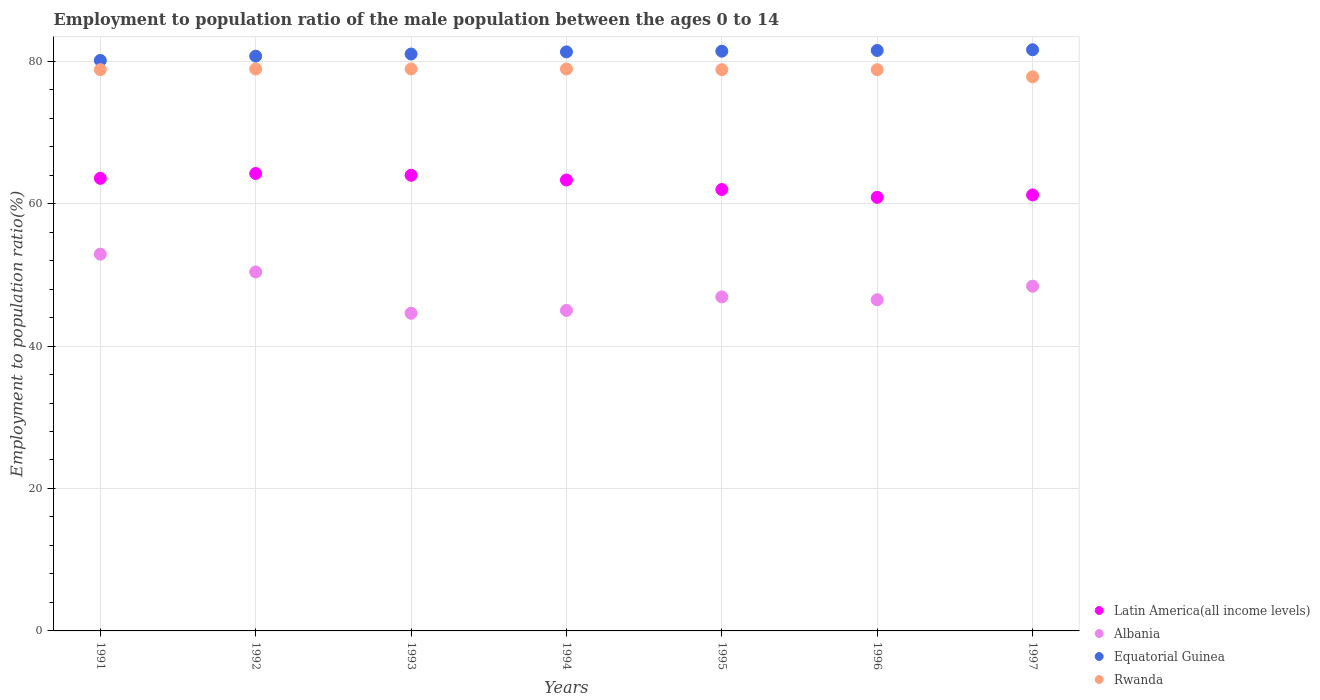Is the number of dotlines equal to the number of legend labels?
Offer a terse response. Yes. What is the employment to population ratio in Albania in 1997?
Offer a very short reply. 48.4. Across all years, what is the maximum employment to population ratio in Latin America(all income levels)?
Make the answer very short. 64.22. Across all years, what is the minimum employment to population ratio in Rwanda?
Provide a succinct answer. 77.8. In which year was the employment to population ratio in Albania maximum?
Keep it short and to the point. 1991. What is the total employment to population ratio in Rwanda in the graph?
Your answer should be very brief. 550.9. What is the difference between the employment to population ratio in Latin America(all income levels) in 1991 and that in 1992?
Offer a very short reply. -0.68. What is the difference between the employment to population ratio in Rwanda in 1994 and the employment to population ratio in Latin America(all income levels) in 1992?
Make the answer very short. 14.68. What is the average employment to population ratio in Albania per year?
Offer a terse response. 47.81. In the year 1996, what is the difference between the employment to population ratio in Latin America(all income levels) and employment to population ratio in Rwanda?
Your answer should be compact. -17.93. In how many years, is the employment to population ratio in Albania greater than 8 %?
Your response must be concise. 7. What is the ratio of the employment to population ratio in Equatorial Guinea in 1996 to that in 1997?
Your answer should be very brief. 1. What is the difference between the highest and the second highest employment to population ratio in Rwanda?
Make the answer very short. 0. What is the difference between the highest and the lowest employment to population ratio in Albania?
Your answer should be compact. 8.3. In how many years, is the employment to population ratio in Latin America(all income levels) greater than the average employment to population ratio in Latin America(all income levels) taken over all years?
Keep it short and to the point. 4. Is it the case that in every year, the sum of the employment to population ratio in Rwanda and employment to population ratio in Albania  is greater than the sum of employment to population ratio in Latin America(all income levels) and employment to population ratio in Equatorial Guinea?
Provide a short and direct response. No. Is it the case that in every year, the sum of the employment to population ratio in Latin America(all income levels) and employment to population ratio in Rwanda  is greater than the employment to population ratio in Equatorial Guinea?
Offer a terse response. Yes. Does the employment to population ratio in Rwanda monotonically increase over the years?
Your response must be concise. No. Is the employment to population ratio in Latin America(all income levels) strictly less than the employment to population ratio in Rwanda over the years?
Ensure brevity in your answer.  Yes. How many years are there in the graph?
Offer a terse response. 7. What is the difference between two consecutive major ticks on the Y-axis?
Provide a short and direct response. 20. Does the graph contain any zero values?
Your answer should be very brief. No. Where does the legend appear in the graph?
Provide a succinct answer. Bottom right. How many legend labels are there?
Provide a short and direct response. 4. How are the legend labels stacked?
Your answer should be very brief. Vertical. What is the title of the graph?
Give a very brief answer. Employment to population ratio of the male population between the ages 0 to 14. Does "Yemen, Rep." appear as one of the legend labels in the graph?
Make the answer very short. No. What is the label or title of the Y-axis?
Ensure brevity in your answer.  Employment to population ratio(%). What is the Employment to population ratio(%) of Latin America(all income levels) in 1991?
Make the answer very short. 63.55. What is the Employment to population ratio(%) in Albania in 1991?
Give a very brief answer. 52.9. What is the Employment to population ratio(%) of Equatorial Guinea in 1991?
Offer a very short reply. 80.1. What is the Employment to population ratio(%) of Rwanda in 1991?
Your response must be concise. 78.8. What is the Employment to population ratio(%) of Latin America(all income levels) in 1992?
Give a very brief answer. 64.22. What is the Employment to population ratio(%) in Albania in 1992?
Your answer should be very brief. 50.4. What is the Employment to population ratio(%) in Equatorial Guinea in 1992?
Your answer should be very brief. 80.7. What is the Employment to population ratio(%) in Rwanda in 1992?
Make the answer very short. 78.9. What is the Employment to population ratio(%) of Latin America(all income levels) in 1993?
Offer a very short reply. 63.98. What is the Employment to population ratio(%) of Albania in 1993?
Your answer should be compact. 44.6. What is the Employment to population ratio(%) in Rwanda in 1993?
Give a very brief answer. 78.9. What is the Employment to population ratio(%) in Latin America(all income levels) in 1994?
Offer a very short reply. 63.31. What is the Employment to population ratio(%) of Equatorial Guinea in 1994?
Make the answer very short. 81.3. What is the Employment to population ratio(%) of Rwanda in 1994?
Offer a very short reply. 78.9. What is the Employment to population ratio(%) in Latin America(all income levels) in 1995?
Your response must be concise. 61.98. What is the Employment to population ratio(%) of Albania in 1995?
Your answer should be compact. 46.9. What is the Employment to population ratio(%) of Equatorial Guinea in 1995?
Make the answer very short. 81.4. What is the Employment to population ratio(%) in Rwanda in 1995?
Offer a very short reply. 78.8. What is the Employment to population ratio(%) in Latin America(all income levels) in 1996?
Your response must be concise. 60.87. What is the Employment to population ratio(%) of Albania in 1996?
Keep it short and to the point. 46.5. What is the Employment to population ratio(%) of Equatorial Guinea in 1996?
Provide a short and direct response. 81.5. What is the Employment to population ratio(%) of Rwanda in 1996?
Your answer should be very brief. 78.8. What is the Employment to population ratio(%) in Latin America(all income levels) in 1997?
Your answer should be compact. 61.22. What is the Employment to population ratio(%) of Albania in 1997?
Your answer should be compact. 48.4. What is the Employment to population ratio(%) in Equatorial Guinea in 1997?
Your answer should be very brief. 81.6. What is the Employment to population ratio(%) of Rwanda in 1997?
Offer a very short reply. 77.8. Across all years, what is the maximum Employment to population ratio(%) of Latin America(all income levels)?
Keep it short and to the point. 64.22. Across all years, what is the maximum Employment to population ratio(%) in Albania?
Offer a terse response. 52.9. Across all years, what is the maximum Employment to population ratio(%) of Equatorial Guinea?
Provide a short and direct response. 81.6. Across all years, what is the maximum Employment to population ratio(%) in Rwanda?
Ensure brevity in your answer.  78.9. Across all years, what is the minimum Employment to population ratio(%) of Latin America(all income levels)?
Your response must be concise. 60.87. Across all years, what is the minimum Employment to population ratio(%) of Albania?
Your answer should be very brief. 44.6. Across all years, what is the minimum Employment to population ratio(%) in Equatorial Guinea?
Provide a succinct answer. 80.1. Across all years, what is the minimum Employment to population ratio(%) in Rwanda?
Make the answer very short. 77.8. What is the total Employment to population ratio(%) in Latin America(all income levels) in the graph?
Ensure brevity in your answer.  439.12. What is the total Employment to population ratio(%) of Albania in the graph?
Offer a terse response. 334.7. What is the total Employment to population ratio(%) of Equatorial Guinea in the graph?
Offer a very short reply. 567.6. What is the total Employment to population ratio(%) in Rwanda in the graph?
Give a very brief answer. 550.9. What is the difference between the Employment to population ratio(%) in Latin America(all income levels) in 1991 and that in 1992?
Provide a short and direct response. -0.68. What is the difference between the Employment to population ratio(%) in Albania in 1991 and that in 1992?
Make the answer very short. 2.5. What is the difference between the Employment to population ratio(%) of Rwanda in 1991 and that in 1992?
Offer a terse response. -0.1. What is the difference between the Employment to population ratio(%) in Latin America(all income levels) in 1991 and that in 1993?
Make the answer very short. -0.43. What is the difference between the Employment to population ratio(%) of Latin America(all income levels) in 1991 and that in 1994?
Ensure brevity in your answer.  0.24. What is the difference between the Employment to population ratio(%) of Albania in 1991 and that in 1994?
Provide a succinct answer. 7.9. What is the difference between the Employment to population ratio(%) in Equatorial Guinea in 1991 and that in 1994?
Offer a terse response. -1.2. What is the difference between the Employment to population ratio(%) of Latin America(all income levels) in 1991 and that in 1995?
Offer a very short reply. 1.57. What is the difference between the Employment to population ratio(%) of Albania in 1991 and that in 1995?
Provide a succinct answer. 6. What is the difference between the Employment to population ratio(%) in Rwanda in 1991 and that in 1995?
Ensure brevity in your answer.  0. What is the difference between the Employment to population ratio(%) of Latin America(all income levels) in 1991 and that in 1996?
Your answer should be very brief. 2.67. What is the difference between the Employment to population ratio(%) in Albania in 1991 and that in 1996?
Ensure brevity in your answer.  6.4. What is the difference between the Employment to population ratio(%) of Equatorial Guinea in 1991 and that in 1996?
Provide a short and direct response. -1.4. What is the difference between the Employment to population ratio(%) in Latin America(all income levels) in 1991 and that in 1997?
Give a very brief answer. 2.33. What is the difference between the Employment to population ratio(%) in Albania in 1991 and that in 1997?
Your response must be concise. 4.5. What is the difference between the Employment to population ratio(%) of Equatorial Guinea in 1991 and that in 1997?
Ensure brevity in your answer.  -1.5. What is the difference between the Employment to population ratio(%) in Rwanda in 1991 and that in 1997?
Your answer should be very brief. 1. What is the difference between the Employment to population ratio(%) in Latin America(all income levels) in 1992 and that in 1993?
Keep it short and to the point. 0.25. What is the difference between the Employment to population ratio(%) of Albania in 1992 and that in 1993?
Your answer should be very brief. 5.8. What is the difference between the Employment to population ratio(%) of Equatorial Guinea in 1992 and that in 1993?
Make the answer very short. -0.3. What is the difference between the Employment to population ratio(%) in Rwanda in 1992 and that in 1993?
Offer a very short reply. 0. What is the difference between the Employment to population ratio(%) of Latin America(all income levels) in 1992 and that in 1994?
Make the answer very short. 0.91. What is the difference between the Employment to population ratio(%) of Albania in 1992 and that in 1994?
Your answer should be very brief. 5.4. What is the difference between the Employment to population ratio(%) in Latin America(all income levels) in 1992 and that in 1995?
Provide a succinct answer. 2.25. What is the difference between the Employment to population ratio(%) of Latin America(all income levels) in 1992 and that in 1996?
Your response must be concise. 3.35. What is the difference between the Employment to population ratio(%) in Latin America(all income levels) in 1992 and that in 1997?
Make the answer very short. 3.01. What is the difference between the Employment to population ratio(%) in Albania in 1992 and that in 1997?
Your answer should be compact. 2. What is the difference between the Employment to population ratio(%) of Equatorial Guinea in 1992 and that in 1997?
Provide a succinct answer. -0.9. What is the difference between the Employment to population ratio(%) of Rwanda in 1992 and that in 1997?
Ensure brevity in your answer.  1.1. What is the difference between the Employment to population ratio(%) of Latin America(all income levels) in 1993 and that in 1994?
Offer a terse response. 0.67. What is the difference between the Employment to population ratio(%) of Latin America(all income levels) in 1993 and that in 1995?
Ensure brevity in your answer.  2. What is the difference between the Employment to population ratio(%) of Equatorial Guinea in 1993 and that in 1995?
Ensure brevity in your answer.  -0.4. What is the difference between the Employment to population ratio(%) of Rwanda in 1993 and that in 1995?
Your answer should be very brief. 0.1. What is the difference between the Employment to population ratio(%) of Latin America(all income levels) in 1993 and that in 1996?
Your answer should be compact. 3.1. What is the difference between the Employment to population ratio(%) in Albania in 1993 and that in 1996?
Offer a very short reply. -1.9. What is the difference between the Employment to population ratio(%) of Equatorial Guinea in 1993 and that in 1996?
Give a very brief answer. -0.5. What is the difference between the Employment to population ratio(%) of Latin America(all income levels) in 1993 and that in 1997?
Offer a terse response. 2.76. What is the difference between the Employment to population ratio(%) of Latin America(all income levels) in 1994 and that in 1995?
Make the answer very short. 1.33. What is the difference between the Employment to population ratio(%) in Rwanda in 1994 and that in 1995?
Ensure brevity in your answer.  0.1. What is the difference between the Employment to population ratio(%) in Latin America(all income levels) in 1994 and that in 1996?
Keep it short and to the point. 2.44. What is the difference between the Employment to population ratio(%) of Albania in 1994 and that in 1996?
Keep it short and to the point. -1.5. What is the difference between the Employment to population ratio(%) of Latin America(all income levels) in 1994 and that in 1997?
Your response must be concise. 2.09. What is the difference between the Employment to population ratio(%) in Equatorial Guinea in 1994 and that in 1997?
Offer a terse response. -0.3. What is the difference between the Employment to population ratio(%) in Latin America(all income levels) in 1995 and that in 1996?
Keep it short and to the point. 1.1. What is the difference between the Employment to population ratio(%) of Albania in 1995 and that in 1996?
Offer a very short reply. 0.4. What is the difference between the Employment to population ratio(%) of Latin America(all income levels) in 1995 and that in 1997?
Ensure brevity in your answer.  0.76. What is the difference between the Employment to population ratio(%) in Latin America(all income levels) in 1996 and that in 1997?
Offer a terse response. -0.34. What is the difference between the Employment to population ratio(%) in Albania in 1996 and that in 1997?
Provide a succinct answer. -1.9. What is the difference between the Employment to population ratio(%) of Equatorial Guinea in 1996 and that in 1997?
Offer a very short reply. -0.1. What is the difference between the Employment to population ratio(%) in Latin America(all income levels) in 1991 and the Employment to population ratio(%) in Albania in 1992?
Provide a short and direct response. 13.15. What is the difference between the Employment to population ratio(%) in Latin America(all income levels) in 1991 and the Employment to population ratio(%) in Equatorial Guinea in 1992?
Give a very brief answer. -17.15. What is the difference between the Employment to population ratio(%) in Latin America(all income levels) in 1991 and the Employment to population ratio(%) in Rwanda in 1992?
Your response must be concise. -15.35. What is the difference between the Employment to population ratio(%) of Albania in 1991 and the Employment to population ratio(%) of Equatorial Guinea in 1992?
Keep it short and to the point. -27.8. What is the difference between the Employment to population ratio(%) in Equatorial Guinea in 1991 and the Employment to population ratio(%) in Rwanda in 1992?
Your answer should be compact. 1.2. What is the difference between the Employment to population ratio(%) in Latin America(all income levels) in 1991 and the Employment to population ratio(%) in Albania in 1993?
Make the answer very short. 18.95. What is the difference between the Employment to population ratio(%) of Latin America(all income levels) in 1991 and the Employment to population ratio(%) of Equatorial Guinea in 1993?
Make the answer very short. -17.45. What is the difference between the Employment to population ratio(%) in Latin America(all income levels) in 1991 and the Employment to population ratio(%) in Rwanda in 1993?
Provide a short and direct response. -15.35. What is the difference between the Employment to population ratio(%) in Albania in 1991 and the Employment to population ratio(%) in Equatorial Guinea in 1993?
Make the answer very short. -28.1. What is the difference between the Employment to population ratio(%) in Albania in 1991 and the Employment to population ratio(%) in Rwanda in 1993?
Provide a succinct answer. -26. What is the difference between the Employment to population ratio(%) in Equatorial Guinea in 1991 and the Employment to population ratio(%) in Rwanda in 1993?
Offer a terse response. 1.2. What is the difference between the Employment to population ratio(%) in Latin America(all income levels) in 1991 and the Employment to population ratio(%) in Albania in 1994?
Your answer should be very brief. 18.55. What is the difference between the Employment to population ratio(%) in Latin America(all income levels) in 1991 and the Employment to population ratio(%) in Equatorial Guinea in 1994?
Provide a short and direct response. -17.75. What is the difference between the Employment to population ratio(%) of Latin America(all income levels) in 1991 and the Employment to population ratio(%) of Rwanda in 1994?
Provide a short and direct response. -15.35. What is the difference between the Employment to population ratio(%) of Albania in 1991 and the Employment to population ratio(%) of Equatorial Guinea in 1994?
Provide a short and direct response. -28.4. What is the difference between the Employment to population ratio(%) in Albania in 1991 and the Employment to population ratio(%) in Rwanda in 1994?
Keep it short and to the point. -26. What is the difference between the Employment to population ratio(%) of Latin America(all income levels) in 1991 and the Employment to population ratio(%) of Albania in 1995?
Give a very brief answer. 16.65. What is the difference between the Employment to population ratio(%) in Latin America(all income levels) in 1991 and the Employment to population ratio(%) in Equatorial Guinea in 1995?
Offer a very short reply. -17.85. What is the difference between the Employment to population ratio(%) of Latin America(all income levels) in 1991 and the Employment to population ratio(%) of Rwanda in 1995?
Offer a terse response. -15.25. What is the difference between the Employment to population ratio(%) of Albania in 1991 and the Employment to population ratio(%) of Equatorial Guinea in 1995?
Make the answer very short. -28.5. What is the difference between the Employment to population ratio(%) in Albania in 1991 and the Employment to population ratio(%) in Rwanda in 1995?
Your response must be concise. -25.9. What is the difference between the Employment to population ratio(%) of Latin America(all income levels) in 1991 and the Employment to population ratio(%) of Albania in 1996?
Keep it short and to the point. 17.05. What is the difference between the Employment to population ratio(%) of Latin America(all income levels) in 1991 and the Employment to population ratio(%) of Equatorial Guinea in 1996?
Your answer should be very brief. -17.95. What is the difference between the Employment to population ratio(%) in Latin America(all income levels) in 1991 and the Employment to population ratio(%) in Rwanda in 1996?
Your answer should be compact. -15.25. What is the difference between the Employment to population ratio(%) of Albania in 1991 and the Employment to population ratio(%) of Equatorial Guinea in 1996?
Keep it short and to the point. -28.6. What is the difference between the Employment to population ratio(%) of Albania in 1991 and the Employment to population ratio(%) of Rwanda in 1996?
Your answer should be compact. -25.9. What is the difference between the Employment to population ratio(%) of Latin America(all income levels) in 1991 and the Employment to population ratio(%) of Albania in 1997?
Your answer should be compact. 15.15. What is the difference between the Employment to population ratio(%) of Latin America(all income levels) in 1991 and the Employment to population ratio(%) of Equatorial Guinea in 1997?
Provide a short and direct response. -18.05. What is the difference between the Employment to population ratio(%) of Latin America(all income levels) in 1991 and the Employment to population ratio(%) of Rwanda in 1997?
Provide a succinct answer. -14.25. What is the difference between the Employment to population ratio(%) of Albania in 1991 and the Employment to population ratio(%) of Equatorial Guinea in 1997?
Provide a short and direct response. -28.7. What is the difference between the Employment to population ratio(%) in Albania in 1991 and the Employment to population ratio(%) in Rwanda in 1997?
Your answer should be compact. -24.9. What is the difference between the Employment to population ratio(%) in Equatorial Guinea in 1991 and the Employment to population ratio(%) in Rwanda in 1997?
Make the answer very short. 2.3. What is the difference between the Employment to population ratio(%) in Latin America(all income levels) in 1992 and the Employment to population ratio(%) in Albania in 1993?
Keep it short and to the point. 19.62. What is the difference between the Employment to population ratio(%) in Latin America(all income levels) in 1992 and the Employment to population ratio(%) in Equatorial Guinea in 1993?
Give a very brief answer. -16.78. What is the difference between the Employment to population ratio(%) of Latin America(all income levels) in 1992 and the Employment to population ratio(%) of Rwanda in 1993?
Your answer should be compact. -14.68. What is the difference between the Employment to population ratio(%) of Albania in 1992 and the Employment to population ratio(%) of Equatorial Guinea in 1993?
Provide a succinct answer. -30.6. What is the difference between the Employment to population ratio(%) in Albania in 1992 and the Employment to population ratio(%) in Rwanda in 1993?
Offer a very short reply. -28.5. What is the difference between the Employment to population ratio(%) in Latin America(all income levels) in 1992 and the Employment to population ratio(%) in Albania in 1994?
Ensure brevity in your answer.  19.22. What is the difference between the Employment to population ratio(%) in Latin America(all income levels) in 1992 and the Employment to population ratio(%) in Equatorial Guinea in 1994?
Keep it short and to the point. -17.08. What is the difference between the Employment to population ratio(%) in Latin America(all income levels) in 1992 and the Employment to population ratio(%) in Rwanda in 1994?
Give a very brief answer. -14.68. What is the difference between the Employment to population ratio(%) in Albania in 1992 and the Employment to population ratio(%) in Equatorial Guinea in 1994?
Your response must be concise. -30.9. What is the difference between the Employment to population ratio(%) in Albania in 1992 and the Employment to population ratio(%) in Rwanda in 1994?
Your answer should be compact. -28.5. What is the difference between the Employment to population ratio(%) in Equatorial Guinea in 1992 and the Employment to population ratio(%) in Rwanda in 1994?
Provide a succinct answer. 1.8. What is the difference between the Employment to population ratio(%) of Latin America(all income levels) in 1992 and the Employment to population ratio(%) of Albania in 1995?
Offer a terse response. 17.32. What is the difference between the Employment to population ratio(%) of Latin America(all income levels) in 1992 and the Employment to population ratio(%) of Equatorial Guinea in 1995?
Provide a succinct answer. -17.18. What is the difference between the Employment to population ratio(%) of Latin America(all income levels) in 1992 and the Employment to population ratio(%) of Rwanda in 1995?
Make the answer very short. -14.58. What is the difference between the Employment to population ratio(%) of Albania in 1992 and the Employment to population ratio(%) of Equatorial Guinea in 1995?
Provide a short and direct response. -31. What is the difference between the Employment to population ratio(%) of Albania in 1992 and the Employment to population ratio(%) of Rwanda in 1995?
Your response must be concise. -28.4. What is the difference between the Employment to population ratio(%) in Latin America(all income levels) in 1992 and the Employment to population ratio(%) in Albania in 1996?
Your answer should be very brief. 17.72. What is the difference between the Employment to population ratio(%) of Latin America(all income levels) in 1992 and the Employment to population ratio(%) of Equatorial Guinea in 1996?
Provide a short and direct response. -17.28. What is the difference between the Employment to population ratio(%) in Latin America(all income levels) in 1992 and the Employment to population ratio(%) in Rwanda in 1996?
Keep it short and to the point. -14.58. What is the difference between the Employment to population ratio(%) of Albania in 1992 and the Employment to population ratio(%) of Equatorial Guinea in 1996?
Provide a succinct answer. -31.1. What is the difference between the Employment to population ratio(%) of Albania in 1992 and the Employment to population ratio(%) of Rwanda in 1996?
Your answer should be compact. -28.4. What is the difference between the Employment to population ratio(%) in Latin America(all income levels) in 1992 and the Employment to population ratio(%) in Albania in 1997?
Keep it short and to the point. 15.82. What is the difference between the Employment to population ratio(%) in Latin America(all income levels) in 1992 and the Employment to population ratio(%) in Equatorial Guinea in 1997?
Provide a short and direct response. -17.38. What is the difference between the Employment to population ratio(%) of Latin America(all income levels) in 1992 and the Employment to population ratio(%) of Rwanda in 1997?
Your answer should be compact. -13.58. What is the difference between the Employment to population ratio(%) of Albania in 1992 and the Employment to population ratio(%) of Equatorial Guinea in 1997?
Provide a succinct answer. -31.2. What is the difference between the Employment to population ratio(%) of Albania in 1992 and the Employment to population ratio(%) of Rwanda in 1997?
Provide a short and direct response. -27.4. What is the difference between the Employment to population ratio(%) in Equatorial Guinea in 1992 and the Employment to population ratio(%) in Rwanda in 1997?
Your answer should be very brief. 2.9. What is the difference between the Employment to population ratio(%) of Latin America(all income levels) in 1993 and the Employment to population ratio(%) of Albania in 1994?
Provide a succinct answer. 18.98. What is the difference between the Employment to population ratio(%) in Latin America(all income levels) in 1993 and the Employment to population ratio(%) in Equatorial Guinea in 1994?
Provide a short and direct response. -17.32. What is the difference between the Employment to population ratio(%) in Latin America(all income levels) in 1993 and the Employment to population ratio(%) in Rwanda in 1994?
Your answer should be very brief. -14.92. What is the difference between the Employment to population ratio(%) of Albania in 1993 and the Employment to population ratio(%) of Equatorial Guinea in 1994?
Your answer should be compact. -36.7. What is the difference between the Employment to population ratio(%) of Albania in 1993 and the Employment to population ratio(%) of Rwanda in 1994?
Your answer should be compact. -34.3. What is the difference between the Employment to population ratio(%) in Equatorial Guinea in 1993 and the Employment to population ratio(%) in Rwanda in 1994?
Provide a succinct answer. 2.1. What is the difference between the Employment to population ratio(%) of Latin America(all income levels) in 1993 and the Employment to population ratio(%) of Albania in 1995?
Keep it short and to the point. 17.08. What is the difference between the Employment to population ratio(%) of Latin America(all income levels) in 1993 and the Employment to population ratio(%) of Equatorial Guinea in 1995?
Your response must be concise. -17.42. What is the difference between the Employment to population ratio(%) of Latin America(all income levels) in 1993 and the Employment to population ratio(%) of Rwanda in 1995?
Provide a short and direct response. -14.82. What is the difference between the Employment to population ratio(%) of Albania in 1993 and the Employment to population ratio(%) of Equatorial Guinea in 1995?
Offer a terse response. -36.8. What is the difference between the Employment to population ratio(%) of Albania in 1993 and the Employment to population ratio(%) of Rwanda in 1995?
Provide a succinct answer. -34.2. What is the difference between the Employment to population ratio(%) in Latin America(all income levels) in 1993 and the Employment to population ratio(%) in Albania in 1996?
Your response must be concise. 17.48. What is the difference between the Employment to population ratio(%) of Latin America(all income levels) in 1993 and the Employment to population ratio(%) of Equatorial Guinea in 1996?
Provide a short and direct response. -17.52. What is the difference between the Employment to population ratio(%) of Latin America(all income levels) in 1993 and the Employment to population ratio(%) of Rwanda in 1996?
Provide a short and direct response. -14.82. What is the difference between the Employment to population ratio(%) in Albania in 1993 and the Employment to population ratio(%) in Equatorial Guinea in 1996?
Provide a succinct answer. -36.9. What is the difference between the Employment to population ratio(%) in Albania in 1993 and the Employment to population ratio(%) in Rwanda in 1996?
Your answer should be compact. -34.2. What is the difference between the Employment to population ratio(%) of Latin America(all income levels) in 1993 and the Employment to population ratio(%) of Albania in 1997?
Offer a terse response. 15.58. What is the difference between the Employment to population ratio(%) of Latin America(all income levels) in 1993 and the Employment to population ratio(%) of Equatorial Guinea in 1997?
Offer a terse response. -17.62. What is the difference between the Employment to population ratio(%) of Latin America(all income levels) in 1993 and the Employment to population ratio(%) of Rwanda in 1997?
Provide a short and direct response. -13.82. What is the difference between the Employment to population ratio(%) of Albania in 1993 and the Employment to population ratio(%) of Equatorial Guinea in 1997?
Your answer should be very brief. -37. What is the difference between the Employment to population ratio(%) in Albania in 1993 and the Employment to population ratio(%) in Rwanda in 1997?
Provide a short and direct response. -33.2. What is the difference between the Employment to population ratio(%) in Latin America(all income levels) in 1994 and the Employment to population ratio(%) in Albania in 1995?
Keep it short and to the point. 16.41. What is the difference between the Employment to population ratio(%) of Latin America(all income levels) in 1994 and the Employment to population ratio(%) of Equatorial Guinea in 1995?
Your answer should be compact. -18.09. What is the difference between the Employment to population ratio(%) in Latin America(all income levels) in 1994 and the Employment to population ratio(%) in Rwanda in 1995?
Your response must be concise. -15.49. What is the difference between the Employment to population ratio(%) in Albania in 1994 and the Employment to population ratio(%) in Equatorial Guinea in 1995?
Provide a short and direct response. -36.4. What is the difference between the Employment to population ratio(%) in Albania in 1994 and the Employment to population ratio(%) in Rwanda in 1995?
Offer a very short reply. -33.8. What is the difference between the Employment to population ratio(%) in Equatorial Guinea in 1994 and the Employment to population ratio(%) in Rwanda in 1995?
Provide a short and direct response. 2.5. What is the difference between the Employment to population ratio(%) of Latin America(all income levels) in 1994 and the Employment to population ratio(%) of Albania in 1996?
Your answer should be very brief. 16.81. What is the difference between the Employment to population ratio(%) in Latin America(all income levels) in 1994 and the Employment to population ratio(%) in Equatorial Guinea in 1996?
Your response must be concise. -18.19. What is the difference between the Employment to population ratio(%) in Latin America(all income levels) in 1994 and the Employment to population ratio(%) in Rwanda in 1996?
Provide a succinct answer. -15.49. What is the difference between the Employment to population ratio(%) in Albania in 1994 and the Employment to population ratio(%) in Equatorial Guinea in 1996?
Keep it short and to the point. -36.5. What is the difference between the Employment to population ratio(%) of Albania in 1994 and the Employment to population ratio(%) of Rwanda in 1996?
Give a very brief answer. -33.8. What is the difference between the Employment to population ratio(%) of Latin America(all income levels) in 1994 and the Employment to population ratio(%) of Albania in 1997?
Provide a succinct answer. 14.91. What is the difference between the Employment to population ratio(%) in Latin America(all income levels) in 1994 and the Employment to population ratio(%) in Equatorial Guinea in 1997?
Offer a terse response. -18.29. What is the difference between the Employment to population ratio(%) of Latin America(all income levels) in 1994 and the Employment to population ratio(%) of Rwanda in 1997?
Your answer should be very brief. -14.49. What is the difference between the Employment to population ratio(%) of Albania in 1994 and the Employment to population ratio(%) of Equatorial Guinea in 1997?
Your response must be concise. -36.6. What is the difference between the Employment to population ratio(%) of Albania in 1994 and the Employment to population ratio(%) of Rwanda in 1997?
Keep it short and to the point. -32.8. What is the difference between the Employment to population ratio(%) of Latin America(all income levels) in 1995 and the Employment to population ratio(%) of Albania in 1996?
Your answer should be compact. 15.48. What is the difference between the Employment to population ratio(%) of Latin America(all income levels) in 1995 and the Employment to population ratio(%) of Equatorial Guinea in 1996?
Offer a very short reply. -19.52. What is the difference between the Employment to population ratio(%) in Latin America(all income levels) in 1995 and the Employment to population ratio(%) in Rwanda in 1996?
Your response must be concise. -16.82. What is the difference between the Employment to population ratio(%) in Albania in 1995 and the Employment to population ratio(%) in Equatorial Guinea in 1996?
Keep it short and to the point. -34.6. What is the difference between the Employment to population ratio(%) in Albania in 1995 and the Employment to population ratio(%) in Rwanda in 1996?
Keep it short and to the point. -31.9. What is the difference between the Employment to population ratio(%) of Equatorial Guinea in 1995 and the Employment to population ratio(%) of Rwanda in 1996?
Your answer should be compact. 2.6. What is the difference between the Employment to population ratio(%) in Latin America(all income levels) in 1995 and the Employment to population ratio(%) in Albania in 1997?
Your answer should be very brief. 13.58. What is the difference between the Employment to population ratio(%) in Latin America(all income levels) in 1995 and the Employment to population ratio(%) in Equatorial Guinea in 1997?
Provide a short and direct response. -19.62. What is the difference between the Employment to population ratio(%) in Latin America(all income levels) in 1995 and the Employment to population ratio(%) in Rwanda in 1997?
Your answer should be compact. -15.82. What is the difference between the Employment to population ratio(%) in Albania in 1995 and the Employment to population ratio(%) in Equatorial Guinea in 1997?
Your answer should be compact. -34.7. What is the difference between the Employment to population ratio(%) in Albania in 1995 and the Employment to population ratio(%) in Rwanda in 1997?
Keep it short and to the point. -30.9. What is the difference between the Employment to population ratio(%) of Equatorial Guinea in 1995 and the Employment to population ratio(%) of Rwanda in 1997?
Your response must be concise. 3.6. What is the difference between the Employment to population ratio(%) in Latin America(all income levels) in 1996 and the Employment to population ratio(%) in Albania in 1997?
Give a very brief answer. 12.47. What is the difference between the Employment to population ratio(%) in Latin America(all income levels) in 1996 and the Employment to population ratio(%) in Equatorial Guinea in 1997?
Ensure brevity in your answer.  -20.73. What is the difference between the Employment to population ratio(%) of Latin America(all income levels) in 1996 and the Employment to population ratio(%) of Rwanda in 1997?
Your answer should be very brief. -16.93. What is the difference between the Employment to population ratio(%) of Albania in 1996 and the Employment to population ratio(%) of Equatorial Guinea in 1997?
Ensure brevity in your answer.  -35.1. What is the difference between the Employment to population ratio(%) of Albania in 1996 and the Employment to population ratio(%) of Rwanda in 1997?
Keep it short and to the point. -31.3. What is the difference between the Employment to population ratio(%) in Equatorial Guinea in 1996 and the Employment to population ratio(%) in Rwanda in 1997?
Your answer should be very brief. 3.7. What is the average Employment to population ratio(%) of Latin America(all income levels) per year?
Offer a very short reply. 62.73. What is the average Employment to population ratio(%) in Albania per year?
Ensure brevity in your answer.  47.81. What is the average Employment to population ratio(%) in Equatorial Guinea per year?
Ensure brevity in your answer.  81.09. What is the average Employment to population ratio(%) of Rwanda per year?
Ensure brevity in your answer.  78.7. In the year 1991, what is the difference between the Employment to population ratio(%) of Latin America(all income levels) and Employment to population ratio(%) of Albania?
Offer a terse response. 10.65. In the year 1991, what is the difference between the Employment to population ratio(%) in Latin America(all income levels) and Employment to population ratio(%) in Equatorial Guinea?
Provide a succinct answer. -16.55. In the year 1991, what is the difference between the Employment to population ratio(%) in Latin America(all income levels) and Employment to population ratio(%) in Rwanda?
Keep it short and to the point. -15.25. In the year 1991, what is the difference between the Employment to population ratio(%) in Albania and Employment to population ratio(%) in Equatorial Guinea?
Provide a succinct answer. -27.2. In the year 1991, what is the difference between the Employment to population ratio(%) of Albania and Employment to population ratio(%) of Rwanda?
Make the answer very short. -25.9. In the year 1991, what is the difference between the Employment to population ratio(%) of Equatorial Guinea and Employment to population ratio(%) of Rwanda?
Make the answer very short. 1.3. In the year 1992, what is the difference between the Employment to population ratio(%) in Latin America(all income levels) and Employment to population ratio(%) in Albania?
Offer a terse response. 13.82. In the year 1992, what is the difference between the Employment to population ratio(%) in Latin America(all income levels) and Employment to population ratio(%) in Equatorial Guinea?
Your answer should be very brief. -16.48. In the year 1992, what is the difference between the Employment to population ratio(%) in Latin America(all income levels) and Employment to population ratio(%) in Rwanda?
Offer a terse response. -14.68. In the year 1992, what is the difference between the Employment to population ratio(%) of Albania and Employment to population ratio(%) of Equatorial Guinea?
Give a very brief answer. -30.3. In the year 1992, what is the difference between the Employment to population ratio(%) of Albania and Employment to population ratio(%) of Rwanda?
Make the answer very short. -28.5. In the year 1992, what is the difference between the Employment to population ratio(%) in Equatorial Guinea and Employment to population ratio(%) in Rwanda?
Make the answer very short. 1.8. In the year 1993, what is the difference between the Employment to population ratio(%) in Latin America(all income levels) and Employment to population ratio(%) in Albania?
Offer a terse response. 19.38. In the year 1993, what is the difference between the Employment to population ratio(%) in Latin America(all income levels) and Employment to population ratio(%) in Equatorial Guinea?
Keep it short and to the point. -17.02. In the year 1993, what is the difference between the Employment to population ratio(%) in Latin America(all income levels) and Employment to population ratio(%) in Rwanda?
Provide a short and direct response. -14.92. In the year 1993, what is the difference between the Employment to population ratio(%) in Albania and Employment to population ratio(%) in Equatorial Guinea?
Your answer should be compact. -36.4. In the year 1993, what is the difference between the Employment to population ratio(%) of Albania and Employment to population ratio(%) of Rwanda?
Provide a short and direct response. -34.3. In the year 1994, what is the difference between the Employment to population ratio(%) of Latin America(all income levels) and Employment to population ratio(%) of Albania?
Ensure brevity in your answer.  18.31. In the year 1994, what is the difference between the Employment to population ratio(%) in Latin America(all income levels) and Employment to population ratio(%) in Equatorial Guinea?
Provide a short and direct response. -17.99. In the year 1994, what is the difference between the Employment to population ratio(%) in Latin America(all income levels) and Employment to population ratio(%) in Rwanda?
Make the answer very short. -15.59. In the year 1994, what is the difference between the Employment to population ratio(%) in Albania and Employment to population ratio(%) in Equatorial Guinea?
Provide a short and direct response. -36.3. In the year 1994, what is the difference between the Employment to population ratio(%) of Albania and Employment to population ratio(%) of Rwanda?
Provide a short and direct response. -33.9. In the year 1995, what is the difference between the Employment to population ratio(%) in Latin America(all income levels) and Employment to population ratio(%) in Albania?
Give a very brief answer. 15.08. In the year 1995, what is the difference between the Employment to population ratio(%) of Latin America(all income levels) and Employment to population ratio(%) of Equatorial Guinea?
Your answer should be very brief. -19.42. In the year 1995, what is the difference between the Employment to population ratio(%) in Latin America(all income levels) and Employment to population ratio(%) in Rwanda?
Offer a terse response. -16.82. In the year 1995, what is the difference between the Employment to population ratio(%) of Albania and Employment to population ratio(%) of Equatorial Guinea?
Ensure brevity in your answer.  -34.5. In the year 1995, what is the difference between the Employment to population ratio(%) in Albania and Employment to population ratio(%) in Rwanda?
Make the answer very short. -31.9. In the year 1995, what is the difference between the Employment to population ratio(%) of Equatorial Guinea and Employment to population ratio(%) of Rwanda?
Ensure brevity in your answer.  2.6. In the year 1996, what is the difference between the Employment to population ratio(%) of Latin America(all income levels) and Employment to population ratio(%) of Albania?
Offer a very short reply. 14.37. In the year 1996, what is the difference between the Employment to population ratio(%) of Latin America(all income levels) and Employment to population ratio(%) of Equatorial Guinea?
Your answer should be compact. -20.63. In the year 1996, what is the difference between the Employment to population ratio(%) in Latin America(all income levels) and Employment to population ratio(%) in Rwanda?
Offer a terse response. -17.93. In the year 1996, what is the difference between the Employment to population ratio(%) in Albania and Employment to population ratio(%) in Equatorial Guinea?
Ensure brevity in your answer.  -35. In the year 1996, what is the difference between the Employment to population ratio(%) in Albania and Employment to population ratio(%) in Rwanda?
Offer a terse response. -32.3. In the year 1997, what is the difference between the Employment to population ratio(%) of Latin America(all income levels) and Employment to population ratio(%) of Albania?
Your answer should be compact. 12.82. In the year 1997, what is the difference between the Employment to population ratio(%) of Latin America(all income levels) and Employment to population ratio(%) of Equatorial Guinea?
Give a very brief answer. -20.38. In the year 1997, what is the difference between the Employment to population ratio(%) of Latin America(all income levels) and Employment to population ratio(%) of Rwanda?
Give a very brief answer. -16.58. In the year 1997, what is the difference between the Employment to population ratio(%) in Albania and Employment to population ratio(%) in Equatorial Guinea?
Provide a short and direct response. -33.2. In the year 1997, what is the difference between the Employment to population ratio(%) in Albania and Employment to population ratio(%) in Rwanda?
Give a very brief answer. -29.4. What is the ratio of the Employment to population ratio(%) in Latin America(all income levels) in 1991 to that in 1992?
Your answer should be compact. 0.99. What is the ratio of the Employment to population ratio(%) in Albania in 1991 to that in 1992?
Your answer should be compact. 1.05. What is the ratio of the Employment to population ratio(%) of Latin America(all income levels) in 1991 to that in 1993?
Keep it short and to the point. 0.99. What is the ratio of the Employment to population ratio(%) in Albania in 1991 to that in 1993?
Offer a very short reply. 1.19. What is the ratio of the Employment to population ratio(%) of Equatorial Guinea in 1991 to that in 1993?
Your answer should be compact. 0.99. What is the ratio of the Employment to population ratio(%) in Albania in 1991 to that in 1994?
Your answer should be very brief. 1.18. What is the ratio of the Employment to population ratio(%) in Equatorial Guinea in 1991 to that in 1994?
Ensure brevity in your answer.  0.99. What is the ratio of the Employment to population ratio(%) in Latin America(all income levels) in 1991 to that in 1995?
Ensure brevity in your answer.  1.03. What is the ratio of the Employment to population ratio(%) of Albania in 1991 to that in 1995?
Provide a short and direct response. 1.13. What is the ratio of the Employment to population ratio(%) of Equatorial Guinea in 1991 to that in 1995?
Give a very brief answer. 0.98. What is the ratio of the Employment to population ratio(%) of Rwanda in 1991 to that in 1995?
Make the answer very short. 1. What is the ratio of the Employment to population ratio(%) of Latin America(all income levels) in 1991 to that in 1996?
Give a very brief answer. 1.04. What is the ratio of the Employment to population ratio(%) in Albania in 1991 to that in 1996?
Your answer should be very brief. 1.14. What is the ratio of the Employment to population ratio(%) of Equatorial Guinea in 1991 to that in 1996?
Make the answer very short. 0.98. What is the ratio of the Employment to population ratio(%) of Rwanda in 1991 to that in 1996?
Provide a short and direct response. 1. What is the ratio of the Employment to population ratio(%) of Latin America(all income levels) in 1991 to that in 1997?
Provide a short and direct response. 1.04. What is the ratio of the Employment to population ratio(%) in Albania in 1991 to that in 1997?
Your response must be concise. 1.09. What is the ratio of the Employment to population ratio(%) in Equatorial Guinea in 1991 to that in 1997?
Ensure brevity in your answer.  0.98. What is the ratio of the Employment to population ratio(%) in Rwanda in 1991 to that in 1997?
Make the answer very short. 1.01. What is the ratio of the Employment to population ratio(%) in Latin America(all income levels) in 1992 to that in 1993?
Make the answer very short. 1. What is the ratio of the Employment to population ratio(%) of Albania in 1992 to that in 1993?
Provide a short and direct response. 1.13. What is the ratio of the Employment to population ratio(%) of Latin America(all income levels) in 1992 to that in 1994?
Your answer should be very brief. 1.01. What is the ratio of the Employment to population ratio(%) of Albania in 1992 to that in 1994?
Offer a terse response. 1.12. What is the ratio of the Employment to population ratio(%) in Latin America(all income levels) in 1992 to that in 1995?
Offer a terse response. 1.04. What is the ratio of the Employment to population ratio(%) of Albania in 1992 to that in 1995?
Your answer should be very brief. 1.07. What is the ratio of the Employment to population ratio(%) in Latin America(all income levels) in 1992 to that in 1996?
Give a very brief answer. 1.05. What is the ratio of the Employment to population ratio(%) in Albania in 1992 to that in 1996?
Give a very brief answer. 1.08. What is the ratio of the Employment to population ratio(%) in Equatorial Guinea in 1992 to that in 1996?
Make the answer very short. 0.99. What is the ratio of the Employment to population ratio(%) in Latin America(all income levels) in 1992 to that in 1997?
Your answer should be compact. 1.05. What is the ratio of the Employment to population ratio(%) in Albania in 1992 to that in 1997?
Make the answer very short. 1.04. What is the ratio of the Employment to population ratio(%) in Rwanda in 1992 to that in 1997?
Give a very brief answer. 1.01. What is the ratio of the Employment to population ratio(%) of Latin America(all income levels) in 1993 to that in 1994?
Offer a terse response. 1.01. What is the ratio of the Employment to population ratio(%) in Equatorial Guinea in 1993 to that in 1994?
Your answer should be very brief. 1. What is the ratio of the Employment to population ratio(%) in Latin America(all income levels) in 1993 to that in 1995?
Make the answer very short. 1.03. What is the ratio of the Employment to population ratio(%) in Albania in 1993 to that in 1995?
Make the answer very short. 0.95. What is the ratio of the Employment to population ratio(%) of Equatorial Guinea in 1993 to that in 1995?
Make the answer very short. 1. What is the ratio of the Employment to population ratio(%) of Latin America(all income levels) in 1993 to that in 1996?
Ensure brevity in your answer.  1.05. What is the ratio of the Employment to population ratio(%) in Albania in 1993 to that in 1996?
Provide a short and direct response. 0.96. What is the ratio of the Employment to population ratio(%) of Latin America(all income levels) in 1993 to that in 1997?
Offer a terse response. 1.05. What is the ratio of the Employment to population ratio(%) of Albania in 1993 to that in 1997?
Your response must be concise. 0.92. What is the ratio of the Employment to population ratio(%) in Rwanda in 1993 to that in 1997?
Give a very brief answer. 1.01. What is the ratio of the Employment to population ratio(%) in Latin America(all income levels) in 1994 to that in 1995?
Offer a terse response. 1.02. What is the ratio of the Employment to population ratio(%) of Albania in 1994 to that in 1995?
Provide a succinct answer. 0.96. What is the ratio of the Employment to population ratio(%) in Rwanda in 1994 to that in 1995?
Ensure brevity in your answer.  1. What is the ratio of the Employment to population ratio(%) in Latin America(all income levels) in 1994 to that in 1996?
Offer a very short reply. 1.04. What is the ratio of the Employment to population ratio(%) of Rwanda in 1994 to that in 1996?
Keep it short and to the point. 1. What is the ratio of the Employment to population ratio(%) of Latin America(all income levels) in 1994 to that in 1997?
Give a very brief answer. 1.03. What is the ratio of the Employment to population ratio(%) of Albania in 1994 to that in 1997?
Your answer should be very brief. 0.93. What is the ratio of the Employment to population ratio(%) in Equatorial Guinea in 1994 to that in 1997?
Your response must be concise. 1. What is the ratio of the Employment to population ratio(%) in Rwanda in 1994 to that in 1997?
Offer a terse response. 1.01. What is the ratio of the Employment to population ratio(%) in Latin America(all income levels) in 1995 to that in 1996?
Your answer should be compact. 1.02. What is the ratio of the Employment to population ratio(%) in Albania in 1995 to that in 1996?
Give a very brief answer. 1.01. What is the ratio of the Employment to population ratio(%) in Latin America(all income levels) in 1995 to that in 1997?
Provide a short and direct response. 1.01. What is the ratio of the Employment to population ratio(%) in Equatorial Guinea in 1995 to that in 1997?
Make the answer very short. 1. What is the ratio of the Employment to population ratio(%) in Rwanda in 1995 to that in 1997?
Your answer should be very brief. 1.01. What is the ratio of the Employment to population ratio(%) in Latin America(all income levels) in 1996 to that in 1997?
Your response must be concise. 0.99. What is the ratio of the Employment to population ratio(%) in Albania in 1996 to that in 1997?
Keep it short and to the point. 0.96. What is the ratio of the Employment to population ratio(%) of Equatorial Guinea in 1996 to that in 1997?
Ensure brevity in your answer.  1. What is the ratio of the Employment to population ratio(%) of Rwanda in 1996 to that in 1997?
Offer a very short reply. 1.01. What is the difference between the highest and the second highest Employment to population ratio(%) of Latin America(all income levels)?
Your answer should be compact. 0.25. What is the difference between the highest and the second highest Employment to population ratio(%) of Albania?
Provide a short and direct response. 2.5. What is the difference between the highest and the second highest Employment to population ratio(%) of Equatorial Guinea?
Your answer should be compact. 0.1. What is the difference between the highest and the second highest Employment to population ratio(%) of Rwanda?
Give a very brief answer. 0. What is the difference between the highest and the lowest Employment to population ratio(%) in Latin America(all income levels)?
Keep it short and to the point. 3.35. What is the difference between the highest and the lowest Employment to population ratio(%) in Albania?
Offer a terse response. 8.3. What is the difference between the highest and the lowest Employment to population ratio(%) of Equatorial Guinea?
Give a very brief answer. 1.5. What is the difference between the highest and the lowest Employment to population ratio(%) of Rwanda?
Ensure brevity in your answer.  1.1. 